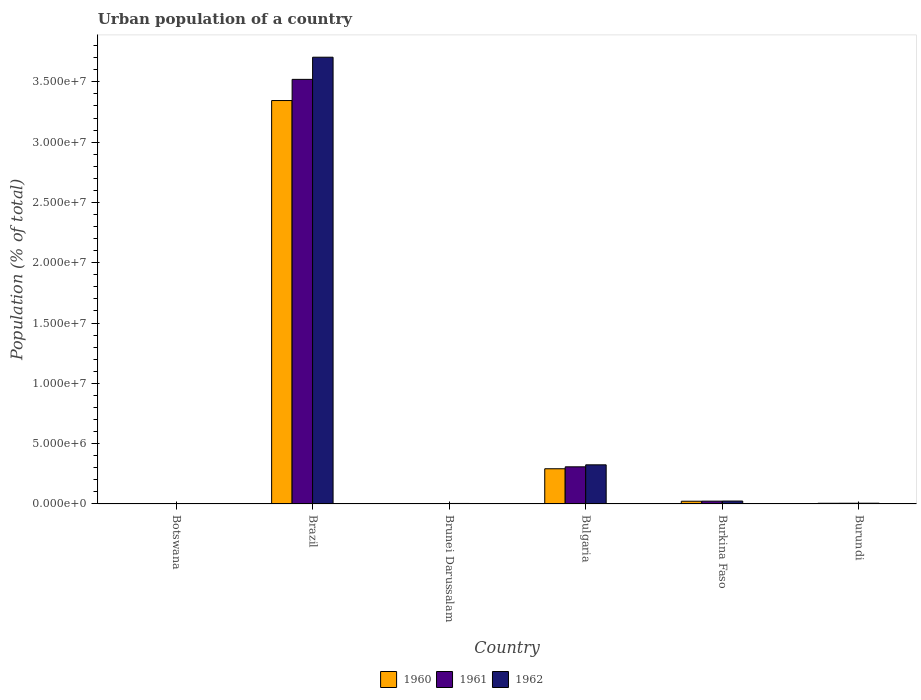Are the number of bars per tick equal to the number of legend labels?
Your response must be concise. Yes. Are the number of bars on each tick of the X-axis equal?
Offer a terse response. Yes. How many bars are there on the 6th tick from the left?
Provide a short and direct response. 3. What is the label of the 5th group of bars from the left?
Provide a succinct answer. Burkina Faso. What is the urban population in 1962 in Botswana?
Your answer should be very brief. 1.72e+04. Across all countries, what is the maximum urban population in 1962?
Your answer should be compact. 3.70e+07. Across all countries, what is the minimum urban population in 1962?
Keep it short and to the point. 1.72e+04. In which country was the urban population in 1961 maximum?
Your answer should be very brief. Brazil. In which country was the urban population in 1960 minimum?
Your answer should be very brief. Botswana. What is the total urban population in 1960 in the graph?
Provide a short and direct response. 3.67e+07. What is the difference between the urban population in 1962 in Botswana and that in Brazil?
Your response must be concise. -3.70e+07. What is the difference between the urban population in 1962 in Burundi and the urban population in 1960 in Brunei Darussalam?
Your answer should be compact. 2.68e+04. What is the average urban population in 1960 per country?
Your response must be concise. 6.12e+06. What is the difference between the urban population of/in 1960 and urban population of/in 1962 in Burundi?
Your response must be concise. -4467. What is the ratio of the urban population in 1962 in Botswana to that in Burkina Faso?
Offer a terse response. 0.07. Is the urban population in 1961 in Bulgaria less than that in Burkina Faso?
Your answer should be very brief. No. What is the difference between the highest and the second highest urban population in 1962?
Give a very brief answer. -3.00e+06. What is the difference between the highest and the lowest urban population in 1962?
Your answer should be very brief. 3.70e+07. In how many countries, is the urban population in 1960 greater than the average urban population in 1960 taken over all countries?
Your response must be concise. 1. What does the 3rd bar from the right in Botswana represents?
Offer a terse response. 1960. Is it the case that in every country, the sum of the urban population in 1962 and urban population in 1960 is greater than the urban population in 1961?
Offer a very short reply. Yes. How many bars are there?
Ensure brevity in your answer.  18. How many countries are there in the graph?
Ensure brevity in your answer.  6. Does the graph contain any zero values?
Your answer should be compact. No. Where does the legend appear in the graph?
Give a very brief answer. Bottom center. How many legend labels are there?
Offer a very short reply. 3. What is the title of the graph?
Keep it short and to the point. Urban population of a country. Does "1964" appear as one of the legend labels in the graph?
Make the answer very short. No. What is the label or title of the Y-axis?
Make the answer very short. Population (% of total). What is the Population (% of total) in 1960 in Botswana?
Provide a short and direct response. 1.60e+04. What is the Population (% of total) of 1961 in Botswana?
Offer a terse response. 1.66e+04. What is the Population (% of total) in 1962 in Botswana?
Provide a short and direct response. 1.72e+04. What is the Population (% of total) in 1960 in Brazil?
Provide a succinct answer. 3.34e+07. What is the Population (% of total) in 1961 in Brazil?
Give a very brief answer. 3.52e+07. What is the Population (% of total) of 1962 in Brazil?
Your response must be concise. 3.70e+07. What is the Population (% of total) of 1960 in Brunei Darussalam?
Offer a very short reply. 3.55e+04. What is the Population (% of total) of 1961 in Brunei Darussalam?
Keep it short and to the point. 3.88e+04. What is the Population (% of total) of 1962 in Brunei Darussalam?
Your response must be concise. 4.22e+04. What is the Population (% of total) in 1960 in Bulgaria?
Your answer should be very brief. 2.92e+06. What is the Population (% of total) in 1961 in Bulgaria?
Provide a succinct answer. 3.08e+06. What is the Population (% of total) of 1962 in Bulgaria?
Give a very brief answer. 3.24e+06. What is the Population (% of total) of 1960 in Burkina Faso?
Your response must be concise. 2.27e+05. What is the Population (% of total) in 1961 in Burkina Faso?
Offer a very short reply. 2.35e+05. What is the Population (% of total) of 1962 in Burkina Faso?
Keep it short and to the point. 2.43e+05. What is the Population (% of total) of 1960 in Burundi?
Make the answer very short. 5.79e+04. What is the Population (% of total) in 1961 in Burundi?
Your answer should be very brief. 6.01e+04. What is the Population (% of total) of 1962 in Burundi?
Ensure brevity in your answer.  6.23e+04. Across all countries, what is the maximum Population (% of total) of 1960?
Your answer should be very brief. 3.34e+07. Across all countries, what is the maximum Population (% of total) of 1961?
Your answer should be very brief. 3.52e+07. Across all countries, what is the maximum Population (% of total) of 1962?
Your response must be concise. 3.70e+07. Across all countries, what is the minimum Population (% of total) of 1960?
Provide a short and direct response. 1.60e+04. Across all countries, what is the minimum Population (% of total) in 1961?
Your answer should be very brief. 1.66e+04. Across all countries, what is the minimum Population (% of total) in 1962?
Provide a short and direct response. 1.72e+04. What is the total Population (% of total) of 1960 in the graph?
Keep it short and to the point. 3.67e+07. What is the total Population (% of total) of 1961 in the graph?
Provide a succinct answer. 3.86e+07. What is the total Population (% of total) in 1962 in the graph?
Make the answer very short. 4.06e+07. What is the difference between the Population (% of total) of 1960 in Botswana and that in Brazil?
Offer a very short reply. -3.34e+07. What is the difference between the Population (% of total) in 1961 in Botswana and that in Brazil?
Provide a short and direct response. -3.52e+07. What is the difference between the Population (% of total) in 1962 in Botswana and that in Brazil?
Give a very brief answer. -3.70e+07. What is the difference between the Population (% of total) of 1960 in Botswana and that in Brunei Darussalam?
Your answer should be compact. -1.95e+04. What is the difference between the Population (% of total) in 1961 in Botswana and that in Brunei Darussalam?
Keep it short and to the point. -2.21e+04. What is the difference between the Population (% of total) of 1962 in Botswana and that in Brunei Darussalam?
Keep it short and to the point. -2.49e+04. What is the difference between the Population (% of total) of 1960 in Botswana and that in Bulgaria?
Make the answer very short. -2.90e+06. What is the difference between the Population (% of total) of 1961 in Botswana and that in Bulgaria?
Your answer should be compact. -3.06e+06. What is the difference between the Population (% of total) of 1962 in Botswana and that in Bulgaria?
Offer a very short reply. -3.23e+06. What is the difference between the Population (% of total) in 1960 in Botswana and that in Burkina Faso?
Ensure brevity in your answer.  -2.11e+05. What is the difference between the Population (% of total) in 1961 in Botswana and that in Burkina Faso?
Give a very brief answer. -2.18e+05. What is the difference between the Population (% of total) of 1962 in Botswana and that in Burkina Faso?
Your answer should be very brief. -2.25e+05. What is the difference between the Population (% of total) of 1960 in Botswana and that in Burundi?
Your answer should be very brief. -4.18e+04. What is the difference between the Population (% of total) of 1961 in Botswana and that in Burundi?
Provide a succinct answer. -4.35e+04. What is the difference between the Population (% of total) of 1962 in Botswana and that in Burundi?
Your answer should be compact. -4.51e+04. What is the difference between the Population (% of total) in 1960 in Brazil and that in Brunei Darussalam?
Ensure brevity in your answer.  3.34e+07. What is the difference between the Population (% of total) in 1961 in Brazil and that in Brunei Darussalam?
Your answer should be very brief. 3.52e+07. What is the difference between the Population (% of total) of 1962 in Brazil and that in Brunei Darussalam?
Your answer should be very brief. 3.70e+07. What is the difference between the Population (% of total) of 1960 in Brazil and that in Bulgaria?
Offer a terse response. 3.05e+07. What is the difference between the Population (% of total) of 1961 in Brazil and that in Bulgaria?
Offer a very short reply. 3.21e+07. What is the difference between the Population (% of total) of 1962 in Brazil and that in Bulgaria?
Keep it short and to the point. 3.38e+07. What is the difference between the Population (% of total) of 1960 in Brazil and that in Burkina Faso?
Provide a succinct answer. 3.32e+07. What is the difference between the Population (% of total) of 1961 in Brazil and that in Burkina Faso?
Your answer should be very brief. 3.50e+07. What is the difference between the Population (% of total) in 1962 in Brazil and that in Burkina Faso?
Your answer should be very brief. 3.68e+07. What is the difference between the Population (% of total) of 1960 in Brazil and that in Burundi?
Your response must be concise. 3.34e+07. What is the difference between the Population (% of total) of 1961 in Brazil and that in Burundi?
Keep it short and to the point. 3.51e+07. What is the difference between the Population (% of total) in 1962 in Brazil and that in Burundi?
Offer a very short reply. 3.70e+07. What is the difference between the Population (% of total) in 1960 in Brunei Darussalam and that in Bulgaria?
Provide a short and direct response. -2.88e+06. What is the difference between the Population (% of total) of 1961 in Brunei Darussalam and that in Bulgaria?
Give a very brief answer. -3.04e+06. What is the difference between the Population (% of total) in 1962 in Brunei Darussalam and that in Bulgaria?
Provide a short and direct response. -3.20e+06. What is the difference between the Population (% of total) of 1960 in Brunei Darussalam and that in Burkina Faso?
Provide a succinct answer. -1.91e+05. What is the difference between the Population (% of total) of 1961 in Brunei Darussalam and that in Burkina Faso?
Offer a very short reply. -1.96e+05. What is the difference between the Population (% of total) in 1962 in Brunei Darussalam and that in Burkina Faso?
Your answer should be compact. -2.01e+05. What is the difference between the Population (% of total) in 1960 in Brunei Darussalam and that in Burundi?
Ensure brevity in your answer.  -2.24e+04. What is the difference between the Population (% of total) of 1961 in Brunei Darussalam and that in Burundi?
Keep it short and to the point. -2.13e+04. What is the difference between the Population (% of total) in 1962 in Brunei Darussalam and that in Burundi?
Your answer should be very brief. -2.02e+04. What is the difference between the Population (% of total) of 1960 in Bulgaria and that in Burkina Faso?
Provide a succinct answer. 2.69e+06. What is the difference between the Population (% of total) in 1961 in Bulgaria and that in Burkina Faso?
Provide a succinct answer. 2.85e+06. What is the difference between the Population (% of total) in 1962 in Bulgaria and that in Burkina Faso?
Offer a very short reply. 3.00e+06. What is the difference between the Population (% of total) in 1960 in Bulgaria and that in Burundi?
Your answer should be compact. 2.86e+06. What is the difference between the Population (% of total) in 1961 in Bulgaria and that in Burundi?
Your answer should be very brief. 3.02e+06. What is the difference between the Population (% of total) in 1962 in Bulgaria and that in Burundi?
Provide a short and direct response. 3.18e+06. What is the difference between the Population (% of total) of 1960 in Burkina Faso and that in Burundi?
Give a very brief answer. 1.69e+05. What is the difference between the Population (% of total) in 1961 in Burkina Faso and that in Burundi?
Provide a succinct answer. 1.75e+05. What is the difference between the Population (% of total) in 1962 in Burkina Faso and that in Burundi?
Your response must be concise. 1.80e+05. What is the difference between the Population (% of total) in 1960 in Botswana and the Population (% of total) in 1961 in Brazil?
Provide a short and direct response. -3.52e+07. What is the difference between the Population (% of total) in 1960 in Botswana and the Population (% of total) in 1962 in Brazil?
Provide a short and direct response. -3.70e+07. What is the difference between the Population (% of total) of 1961 in Botswana and the Population (% of total) of 1962 in Brazil?
Your answer should be very brief. -3.70e+07. What is the difference between the Population (% of total) in 1960 in Botswana and the Population (% of total) in 1961 in Brunei Darussalam?
Your answer should be compact. -2.27e+04. What is the difference between the Population (% of total) of 1960 in Botswana and the Population (% of total) of 1962 in Brunei Darussalam?
Give a very brief answer. -2.61e+04. What is the difference between the Population (% of total) in 1961 in Botswana and the Population (% of total) in 1962 in Brunei Darussalam?
Make the answer very short. -2.56e+04. What is the difference between the Population (% of total) of 1960 in Botswana and the Population (% of total) of 1961 in Bulgaria?
Provide a short and direct response. -3.06e+06. What is the difference between the Population (% of total) of 1960 in Botswana and the Population (% of total) of 1962 in Bulgaria?
Offer a very short reply. -3.23e+06. What is the difference between the Population (% of total) of 1961 in Botswana and the Population (% of total) of 1962 in Bulgaria?
Provide a short and direct response. -3.23e+06. What is the difference between the Population (% of total) of 1960 in Botswana and the Population (% of total) of 1961 in Burkina Faso?
Give a very brief answer. -2.19e+05. What is the difference between the Population (% of total) in 1960 in Botswana and the Population (% of total) in 1962 in Burkina Faso?
Provide a succinct answer. -2.27e+05. What is the difference between the Population (% of total) of 1961 in Botswana and the Population (% of total) of 1962 in Burkina Faso?
Your answer should be compact. -2.26e+05. What is the difference between the Population (% of total) in 1960 in Botswana and the Population (% of total) in 1961 in Burundi?
Your answer should be very brief. -4.40e+04. What is the difference between the Population (% of total) in 1960 in Botswana and the Population (% of total) in 1962 in Burundi?
Give a very brief answer. -4.63e+04. What is the difference between the Population (% of total) of 1961 in Botswana and the Population (% of total) of 1962 in Burundi?
Provide a short and direct response. -4.57e+04. What is the difference between the Population (% of total) of 1960 in Brazil and the Population (% of total) of 1961 in Brunei Darussalam?
Make the answer very short. 3.34e+07. What is the difference between the Population (% of total) of 1960 in Brazil and the Population (% of total) of 1962 in Brunei Darussalam?
Give a very brief answer. 3.34e+07. What is the difference between the Population (% of total) in 1961 in Brazil and the Population (% of total) in 1962 in Brunei Darussalam?
Offer a very short reply. 3.52e+07. What is the difference between the Population (% of total) of 1960 in Brazil and the Population (% of total) of 1961 in Bulgaria?
Offer a very short reply. 3.04e+07. What is the difference between the Population (% of total) of 1960 in Brazil and the Population (% of total) of 1962 in Bulgaria?
Make the answer very short. 3.02e+07. What is the difference between the Population (% of total) of 1961 in Brazil and the Population (% of total) of 1962 in Bulgaria?
Provide a short and direct response. 3.20e+07. What is the difference between the Population (% of total) of 1960 in Brazil and the Population (% of total) of 1961 in Burkina Faso?
Your response must be concise. 3.32e+07. What is the difference between the Population (% of total) of 1960 in Brazil and the Population (% of total) of 1962 in Burkina Faso?
Give a very brief answer. 3.32e+07. What is the difference between the Population (% of total) of 1961 in Brazil and the Population (% of total) of 1962 in Burkina Faso?
Offer a terse response. 3.50e+07. What is the difference between the Population (% of total) of 1960 in Brazil and the Population (% of total) of 1961 in Burundi?
Provide a succinct answer. 3.34e+07. What is the difference between the Population (% of total) in 1960 in Brazil and the Population (% of total) in 1962 in Burundi?
Ensure brevity in your answer.  3.34e+07. What is the difference between the Population (% of total) of 1961 in Brazil and the Population (% of total) of 1962 in Burundi?
Offer a terse response. 3.51e+07. What is the difference between the Population (% of total) in 1960 in Brunei Darussalam and the Population (% of total) in 1961 in Bulgaria?
Provide a succinct answer. -3.04e+06. What is the difference between the Population (% of total) of 1960 in Brunei Darussalam and the Population (% of total) of 1962 in Bulgaria?
Offer a very short reply. -3.21e+06. What is the difference between the Population (% of total) of 1961 in Brunei Darussalam and the Population (% of total) of 1962 in Bulgaria?
Offer a very short reply. -3.21e+06. What is the difference between the Population (% of total) of 1960 in Brunei Darussalam and the Population (% of total) of 1961 in Burkina Faso?
Your answer should be very brief. -1.99e+05. What is the difference between the Population (% of total) of 1960 in Brunei Darussalam and the Population (% of total) of 1962 in Burkina Faso?
Offer a terse response. -2.07e+05. What is the difference between the Population (% of total) in 1961 in Brunei Darussalam and the Population (% of total) in 1962 in Burkina Faso?
Your answer should be very brief. -2.04e+05. What is the difference between the Population (% of total) in 1960 in Brunei Darussalam and the Population (% of total) in 1961 in Burundi?
Make the answer very short. -2.46e+04. What is the difference between the Population (% of total) of 1960 in Brunei Darussalam and the Population (% of total) of 1962 in Burundi?
Make the answer very short. -2.68e+04. What is the difference between the Population (% of total) of 1961 in Brunei Darussalam and the Population (% of total) of 1962 in Burundi?
Give a very brief answer. -2.36e+04. What is the difference between the Population (% of total) in 1960 in Bulgaria and the Population (% of total) in 1961 in Burkina Faso?
Ensure brevity in your answer.  2.68e+06. What is the difference between the Population (% of total) in 1960 in Bulgaria and the Population (% of total) in 1962 in Burkina Faso?
Provide a succinct answer. 2.68e+06. What is the difference between the Population (% of total) of 1961 in Bulgaria and the Population (% of total) of 1962 in Burkina Faso?
Ensure brevity in your answer.  2.84e+06. What is the difference between the Population (% of total) in 1960 in Bulgaria and the Population (% of total) in 1961 in Burundi?
Make the answer very short. 2.86e+06. What is the difference between the Population (% of total) in 1960 in Bulgaria and the Population (% of total) in 1962 in Burundi?
Make the answer very short. 2.86e+06. What is the difference between the Population (% of total) of 1961 in Bulgaria and the Population (% of total) of 1962 in Burundi?
Your answer should be very brief. 3.02e+06. What is the difference between the Population (% of total) in 1960 in Burkina Faso and the Population (% of total) in 1961 in Burundi?
Your answer should be compact. 1.67e+05. What is the difference between the Population (% of total) in 1960 in Burkina Faso and the Population (% of total) in 1962 in Burundi?
Offer a terse response. 1.65e+05. What is the difference between the Population (% of total) in 1961 in Burkina Faso and the Population (% of total) in 1962 in Burundi?
Provide a short and direct response. 1.72e+05. What is the average Population (% of total) of 1960 per country?
Offer a terse response. 6.12e+06. What is the average Population (% of total) of 1961 per country?
Provide a succinct answer. 6.44e+06. What is the average Population (% of total) in 1962 per country?
Provide a short and direct response. 6.77e+06. What is the difference between the Population (% of total) in 1960 and Population (% of total) in 1961 in Botswana?
Provide a succinct answer. -583. What is the difference between the Population (% of total) of 1960 and Population (% of total) of 1962 in Botswana?
Ensure brevity in your answer.  -1202. What is the difference between the Population (% of total) in 1961 and Population (% of total) in 1962 in Botswana?
Make the answer very short. -619. What is the difference between the Population (% of total) of 1960 and Population (% of total) of 1961 in Brazil?
Your response must be concise. -1.76e+06. What is the difference between the Population (% of total) of 1960 and Population (% of total) of 1962 in Brazil?
Your answer should be very brief. -3.59e+06. What is the difference between the Population (% of total) in 1961 and Population (% of total) in 1962 in Brazil?
Your answer should be very brief. -1.84e+06. What is the difference between the Population (% of total) of 1960 and Population (% of total) of 1961 in Brunei Darussalam?
Make the answer very short. -3242. What is the difference between the Population (% of total) of 1960 and Population (% of total) of 1962 in Brunei Darussalam?
Provide a short and direct response. -6663. What is the difference between the Population (% of total) of 1961 and Population (% of total) of 1962 in Brunei Darussalam?
Make the answer very short. -3421. What is the difference between the Population (% of total) of 1960 and Population (% of total) of 1961 in Bulgaria?
Offer a very short reply. -1.62e+05. What is the difference between the Population (% of total) in 1960 and Population (% of total) in 1962 in Bulgaria?
Offer a very short reply. -3.26e+05. What is the difference between the Population (% of total) of 1961 and Population (% of total) of 1962 in Bulgaria?
Offer a very short reply. -1.64e+05. What is the difference between the Population (% of total) of 1960 and Population (% of total) of 1961 in Burkina Faso?
Offer a terse response. -7767. What is the difference between the Population (% of total) of 1960 and Population (% of total) of 1962 in Burkina Faso?
Your answer should be compact. -1.57e+04. What is the difference between the Population (% of total) in 1961 and Population (% of total) in 1962 in Burkina Faso?
Offer a very short reply. -7965. What is the difference between the Population (% of total) of 1960 and Population (% of total) of 1961 in Burundi?
Keep it short and to the point. -2193. What is the difference between the Population (% of total) in 1960 and Population (% of total) in 1962 in Burundi?
Ensure brevity in your answer.  -4467. What is the difference between the Population (% of total) in 1961 and Population (% of total) in 1962 in Burundi?
Offer a very short reply. -2274. What is the ratio of the Population (% of total) in 1962 in Botswana to that in Brazil?
Provide a succinct answer. 0. What is the ratio of the Population (% of total) in 1960 in Botswana to that in Brunei Darussalam?
Your answer should be compact. 0.45. What is the ratio of the Population (% of total) of 1961 in Botswana to that in Brunei Darussalam?
Your response must be concise. 0.43. What is the ratio of the Population (% of total) in 1962 in Botswana to that in Brunei Darussalam?
Give a very brief answer. 0.41. What is the ratio of the Population (% of total) of 1960 in Botswana to that in Bulgaria?
Provide a short and direct response. 0.01. What is the ratio of the Population (% of total) in 1961 in Botswana to that in Bulgaria?
Ensure brevity in your answer.  0.01. What is the ratio of the Population (% of total) in 1962 in Botswana to that in Bulgaria?
Keep it short and to the point. 0.01. What is the ratio of the Population (% of total) of 1960 in Botswana to that in Burkina Faso?
Provide a succinct answer. 0.07. What is the ratio of the Population (% of total) of 1961 in Botswana to that in Burkina Faso?
Make the answer very short. 0.07. What is the ratio of the Population (% of total) of 1962 in Botswana to that in Burkina Faso?
Ensure brevity in your answer.  0.07. What is the ratio of the Population (% of total) in 1960 in Botswana to that in Burundi?
Offer a terse response. 0.28. What is the ratio of the Population (% of total) in 1961 in Botswana to that in Burundi?
Your answer should be very brief. 0.28. What is the ratio of the Population (% of total) of 1962 in Botswana to that in Burundi?
Provide a short and direct response. 0.28. What is the ratio of the Population (% of total) of 1960 in Brazil to that in Brunei Darussalam?
Make the answer very short. 941.85. What is the ratio of the Population (% of total) of 1961 in Brazil to that in Brunei Darussalam?
Offer a terse response. 908.36. What is the ratio of the Population (% of total) in 1962 in Brazil to that in Brunei Darussalam?
Your response must be concise. 878.22. What is the ratio of the Population (% of total) in 1960 in Brazil to that in Bulgaria?
Your answer should be very brief. 11.46. What is the ratio of the Population (% of total) in 1961 in Brazil to that in Bulgaria?
Provide a succinct answer. 11.43. What is the ratio of the Population (% of total) of 1962 in Brazil to that in Bulgaria?
Your answer should be compact. 11.42. What is the ratio of the Population (% of total) of 1960 in Brazil to that in Burkina Faso?
Provide a succinct answer. 147.36. What is the ratio of the Population (% of total) of 1961 in Brazil to that in Burkina Faso?
Your response must be concise. 149.97. What is the ratio of the Population (% of total) of 1962 in Brazil to that in Burkina Faso?
Give a very brief answer. 152.61. What is the ratio of the Population (% of total) in 1960 in Brazil to that in Burundi?
Offer a terse response. 577.87. What is the ratio of the Population (% of total) of 1961 in Brazil to that in Burundi?
Your answer should be very brief. 586. What is the ratio of the Population (% of total) in 1962 in Brazil to that in Burundi?
Keep it short and to the point. 594.08. What is the ratio of the Population (% of total) in 1960 in Brunei Darussalam to that in Bulgaria?
Provide a short and direct response. 0.01. What is the ratio of the Population (% of total) in 1961 in Brunei Darussalam to that in Bulgaria?
Give a very brief answer. 0.01. What is the ratio of the Population (% of total) of 1962 in Brunei Darussalam to that in Bulgaria?
Provide a succinct answer. 0.01. What is the ratio of the Population (% of total) in 1960 in Brunei Darussalam to that in Burkina Faso?
Your answer should be very brief. 0.16. What is the ratio of the Population (% of total) in 1961 in Brunei Darussalam to that in Burkina Faso?
Your answer should be very brief. 0.17. What is the ratio of the Population (% of total) in 1962 in Brunei Darussalam to that in Burkina Faso?
Offer a terse response. 0.17. What is the ratio of the Population (% of total) of 1960 in Brunei Darussalam to that in Burundi?
Provide a succinct answer. 0.61. What is the ratio of the Population (% of total) of 1961 in Brunei Darussalam to that in Burundi?
Offer a very short reply. 0.65. What is the ratio of the Population (% of total) of 1962 in Brunei Darussalam to that in Burundi?
Your response must be concise. 0.68. What is the ratio of the Population (% of total) in 1960 in Bulgaria to that in Burkina Faso?
Offer a terse response. 12.86. What is the ratio of the Population (% of total) of 1961 in Bulgaria to that in Burkina Faso?
Keep it short and to the point. 13.12. What is the ratio of the Population (% of total) in 1962 in Bulgaria to that in Burkina Faso?
Ensure brevity in your answer.  13.37. What is the ratio of the Population (% of total) of 1960 in Bulgaria to that in Burundi?
Make the answer very short. 50.43. What is the ratio of the Population (% of total) of 1961 in Bulgaria to that in Burundi?
Your answer should be compact. 51.28. What is the ratio of the Population (% of total) in 1962 in Bulgaria to that in Burundi?
Your answer should be very brief. 52.04. What is the ratio of the Population (% of total) of 1960 in Burkina Faso to that in Burundi?
Provide a short and direct response. 3.92. What is the ratio of the Population (% of total) of 1961 in Burkina Faso to that in Burundi?
Your response must be concise. 3.91. What is the ratio of the Population (% of total) of 1962 in Burkina Faso to that in Burundi?
Ensure brevity in your answer.  3.89. What is the difference between the highest and the second highest Population (% of total) of 1960?
Keep it short and to the point. 3.05e+07. What is the difference between the highest and the second highest Population (% of total) of 1961?
Your answer should be compact. 3.21e+07. What is the difference between the highest and the second highest Population (% of total) in 1962?
Provide a short and direct response. 3.38e+07. What is the difference between the highest and the lowest Population (% of total) of 1960?
Ensure brevity in your answer.  3.34e+07. What is the difference between the highest and the lowest Population (% of total) of 1961?
Your answer should be very brief. 3.52e+07. What is the difference between the highest and the lowest Population (% of total) in 1962?
Your response must be concise. 3.70e+07. 